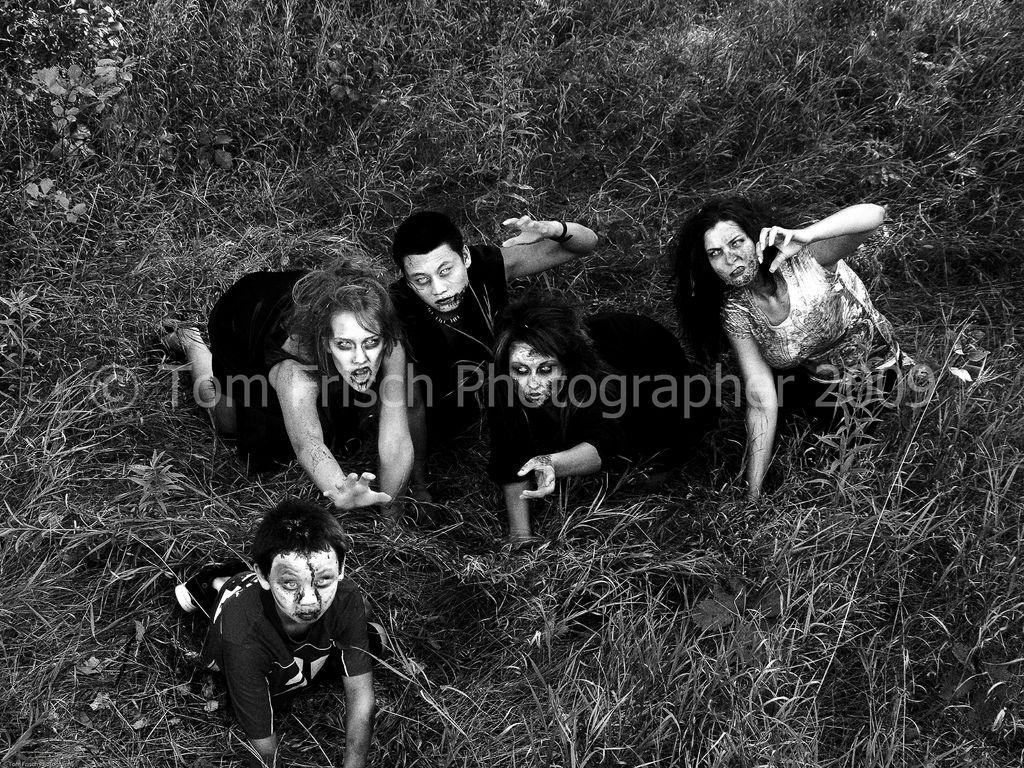What type of picture is in the image? The image contains a black and white picture. What can be seen in the picture? The picture depicts people wearing clothes. What type of natural environment is visible in the picture? There is grass visible in the picture. What is present in the middle of the image? There is a watermark in the middle of the image. Can you see a monkey walking on the grass in the image? No, there is no monkey or any walking figure visible in the image; it contains a picture of people wearing clothes. What type of ink is used for the watermark in the image? There is no information about the type of ink used for the watermark in the image, as the focus is on the picture and its contents. 